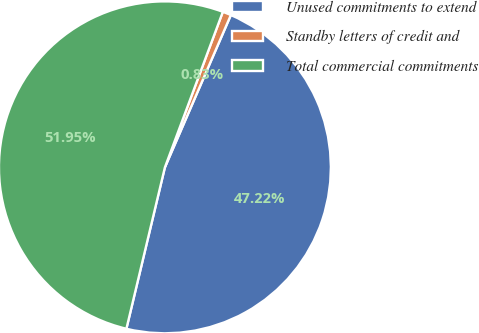<chart> <loc_0><loc_0><loc_500><loc_500><pie_chart><fcel>Unused commitments to extend<fcel>Standby letters of credit and<fcel>Total commercial commitments<nl><fcel>47.22%<fcel>0.83%<fcel>51.95%<nl></chart> 